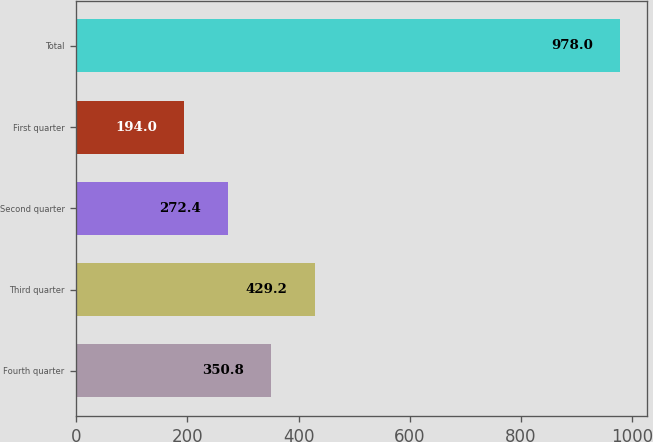<chart> <loc_0><loc_0><loc_500><loc_500><bar_chart><fcel>Fourth quarter<fcel>Third quarter<fcel>Second quarter<fcel>First quarter<fcel>Total<nl><fcel>350.8<fcel>429.2<fcel>272.4<fcel>194<fcel>978<nl></chart> 